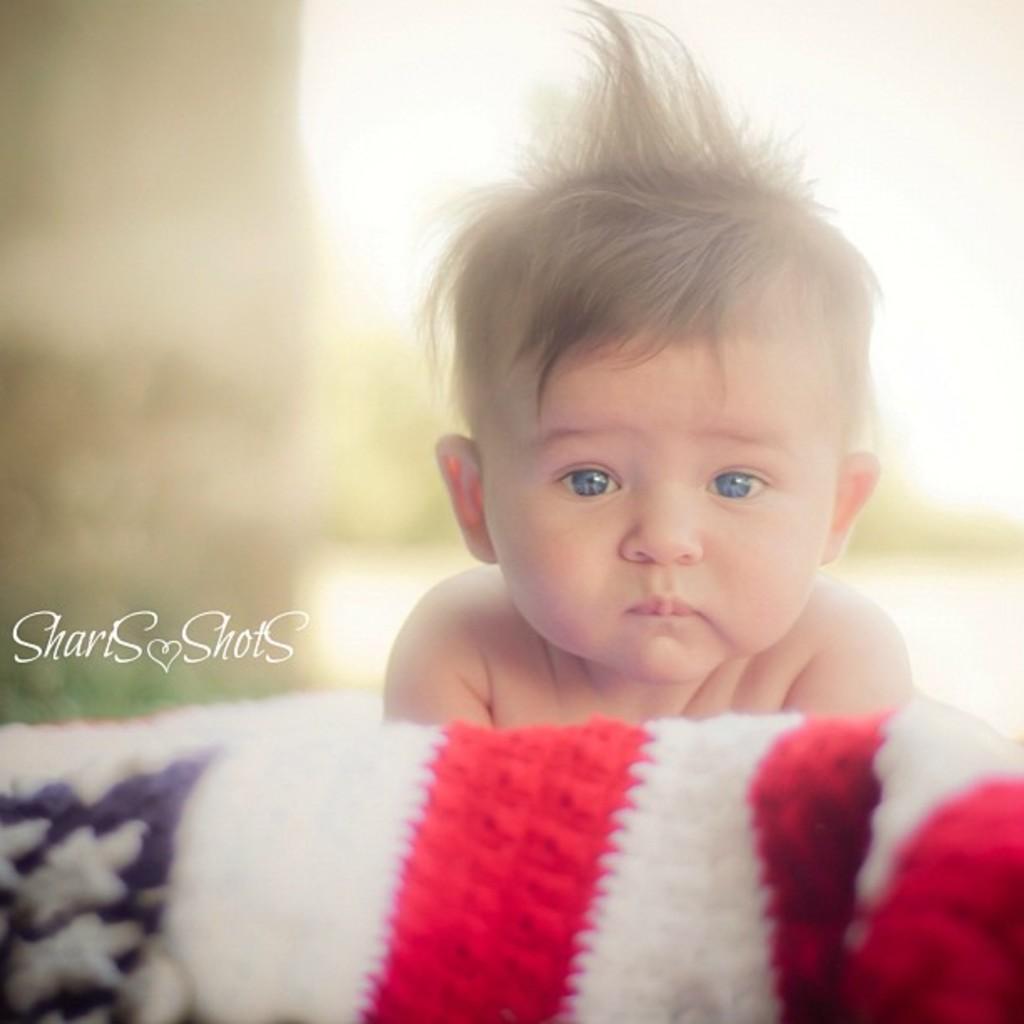Describe this image in one or two sentences. In this image there is a baby , cloth, and there is blur background and a watermark on the image. 